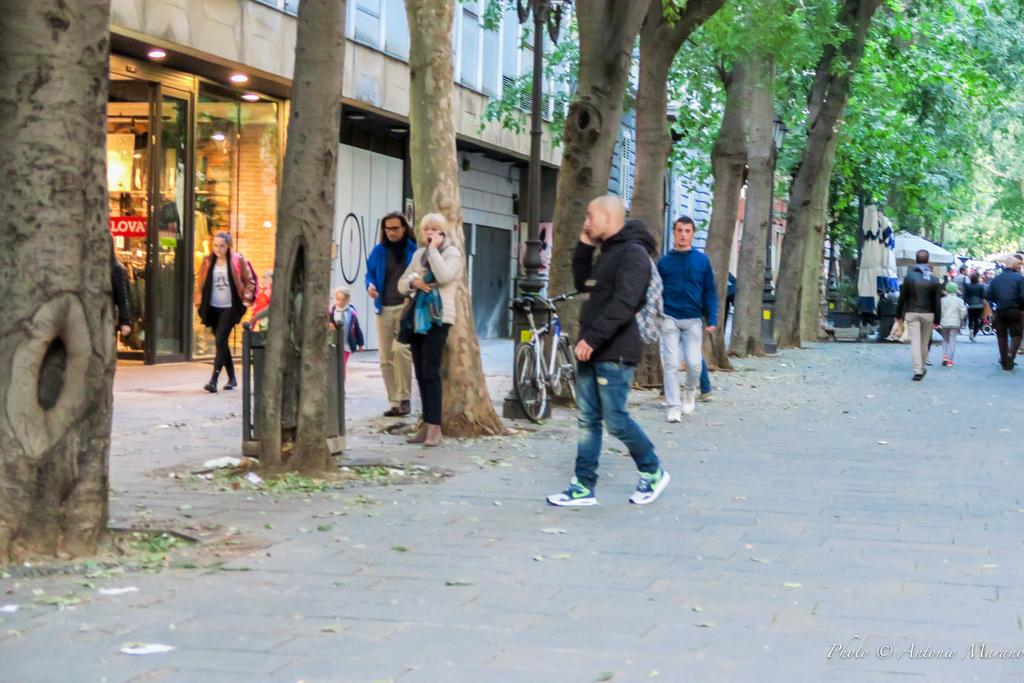What type of natural elements can be seen in the image? There are trees in the image. What type of man-made structures are present in the image? There are buildings in the image. Are there any living beings visible in the image? Yes, there are people in the image. What mode of transportation can be seen in the image? There is a bicycle in the image. Where is the faucet located in the image? There is no faucet present in the image. How many people are in the crowd in the image? There is no crowd present in the image; there are only individual people visible. 